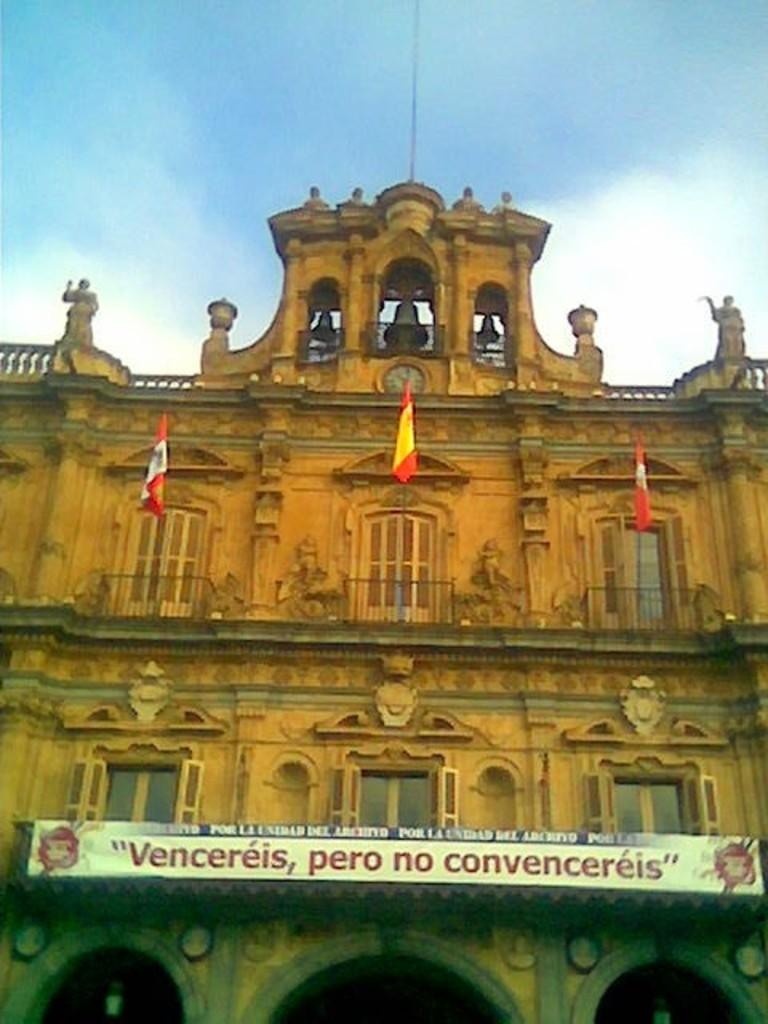What type of structure is visible in the image? There is a building in the image. What can be seen near the building? There are flags and a hoarding near the building. Are there any unique features on the building? Yes, there are bells and sculptures on the building. What is visible in the background of the image? The sky is visible behind the building. What type of shade is provided by the building in the image during the afternoon? The image does not provide information about the shade or the time of day, so it cannot be determined from the image. 